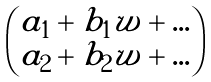Convert formula to latex. <formula><loc_0><loc_0><loc_500><loc_500>\begin{pmatrix} a _ { 1 } + b _ { 1 } w + \dots \\ a _ { 2 } + b _ { 2 } w + \dots \end{pmatrix}</formula> 